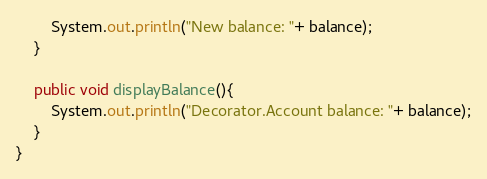<code> <loc_0><loc_0><loc_500><loc_500><_Java_>        System.out.println("New balance: "+ balance);
    }

    public void displayBalance(){
        System.out.println("Decorator.Account balance: "+ balance);
    }
}
</code> 